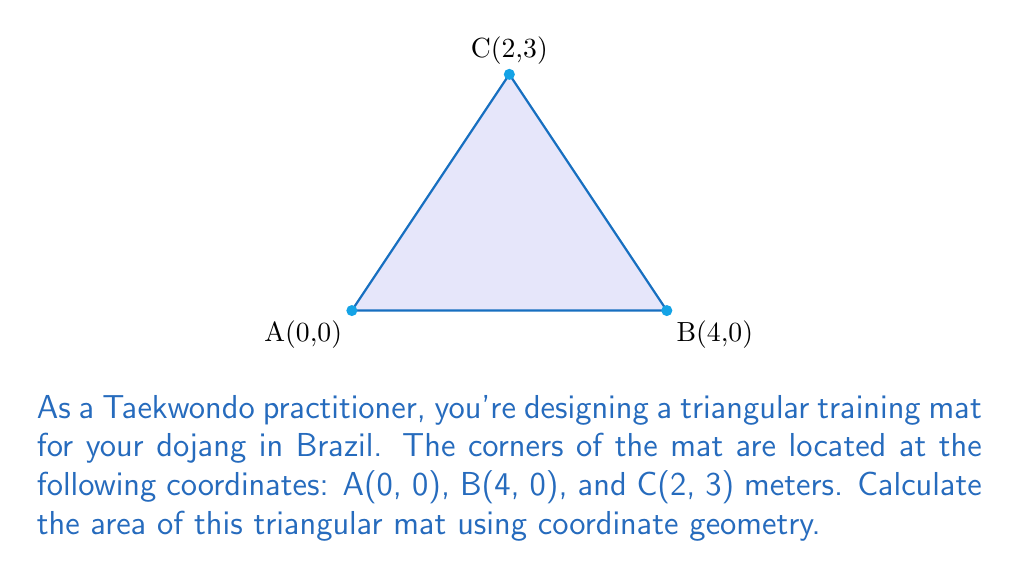Can you answer this question? To calculate the area of a triangle using coordinate geometry, we can use the formula:

$$\text{Area} = \frac{1}{2}|\det(\vec{AB}, \vec{AC})|$$

Where $\vec{AB}$ and $\vec{AC}$ are vectors representing two sides of the triangle, and $\det$ is the determinant.

Step 1: Calculate vectors $\vec{AB}$ and $\vec{AC}$
$\vec{AB} = B - A = (4-0, 0-0) = (4, 0)$
$\vec{AC} = C - A = (2-0, 3-0) = (2, 3)$

Step 2: Set up the determinant
$$\det(\vec{AB}, \vec{AC}) = \begin{vmatrix} 
4 & 2 \\
0 & 3
\end{vmatrix}$$

Step 3: Calculate the determinant
$$\det(\vec{AB}, \vec{AC}) = (4 \times 3) - (2 \times 0) = 12 - 0 = 12$$

Step 4: Apply the area formula
$$\text{Area} = \frac{1}{2}|12| = 6$$

Therefore, the area of the triangular training mat is 6 square meters.
Answer: $6 \text{ m}^2$ 